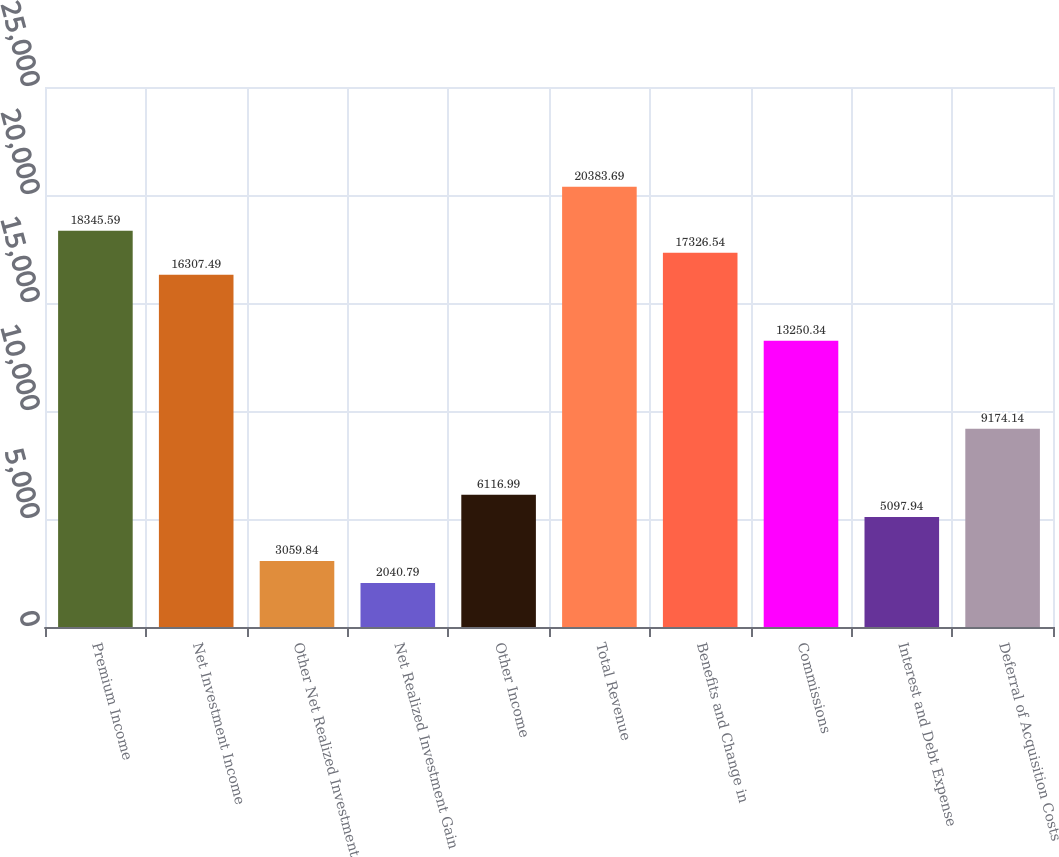Convert chart to OTSL. <chart><loc_0><loc_0><loc_500><loc_500><bar_chart><fcel>Premium Income<fcel>Net Investment Income<fcel>Other Net Realized Investment<fcel>Net Realized Investment Gain<fcel>Other Income<fcel>Total Revenue<fcel>Benefits and Change in<fcel>Commissions<fcel>Interest and Debt Expense<fcel>Deferral of Acquisition Costs<nl><fcel>18345.6<fcel>16307.5<fcel>3059.84<fcel>2040.79<fcel>6116.99<fcel>20383.7<fcel>17326.5<fcel>13250.3<fcel>5097.94<fcel>9174.14<nl></chart> 